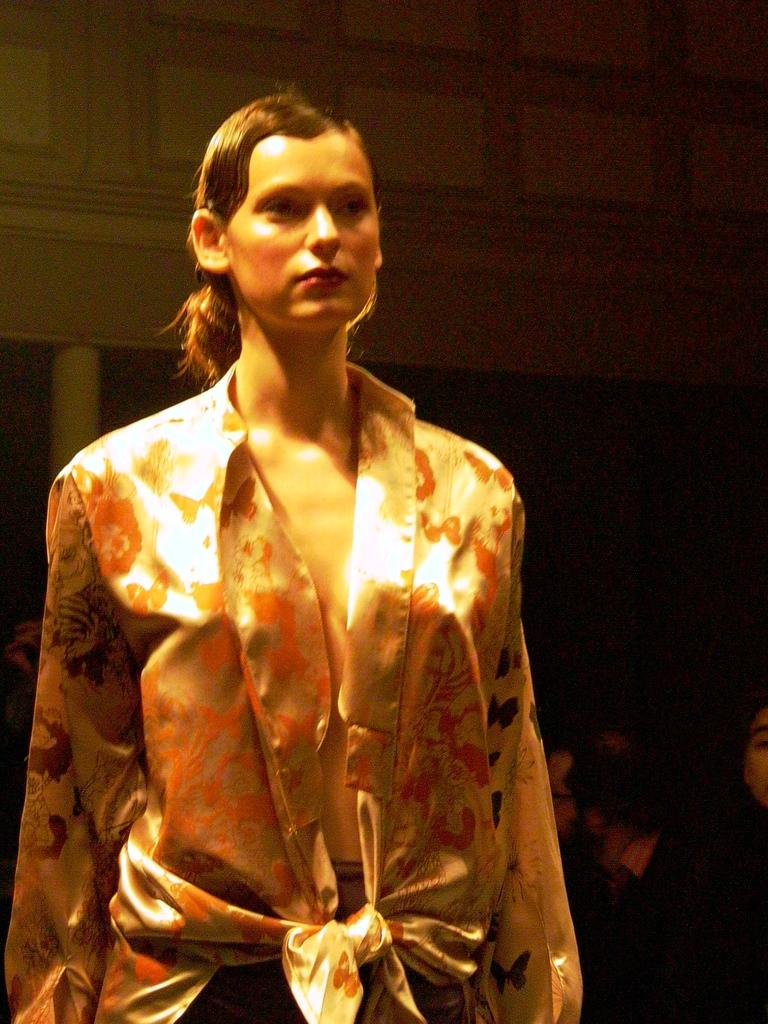Who is present in the image? There is a woman in the image. What is the woman doing in the image? The woman is standing. What type of balls can be seen in the cemetery in the image? There is no cemetery or balls present in the image; it features a woman standing. 